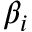Convert formula to latex. <formula><loc_0><loc_0><loc_500><loc_500>\beta _ { i }</formula> 